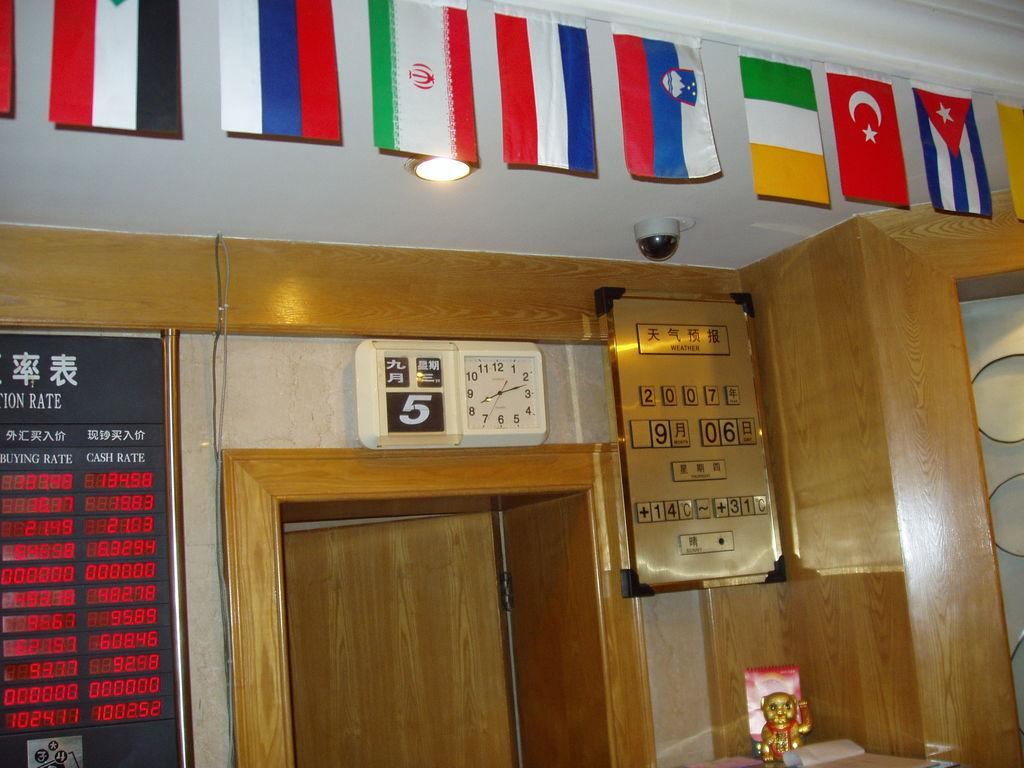What is located in the middle of the image? There is a door in the middle of the image. What can be seen at the top of the image? There is a light at the top of the image. What device is on the right side of the image? There is a camera on the right side of the image. What type of winter clothing is being washed in the image? There is no winter clothing or washing activity present in the image. What downtown area is depicted in the image? The image does not depict a downtown area; it only features a door, a light, and a camera. 